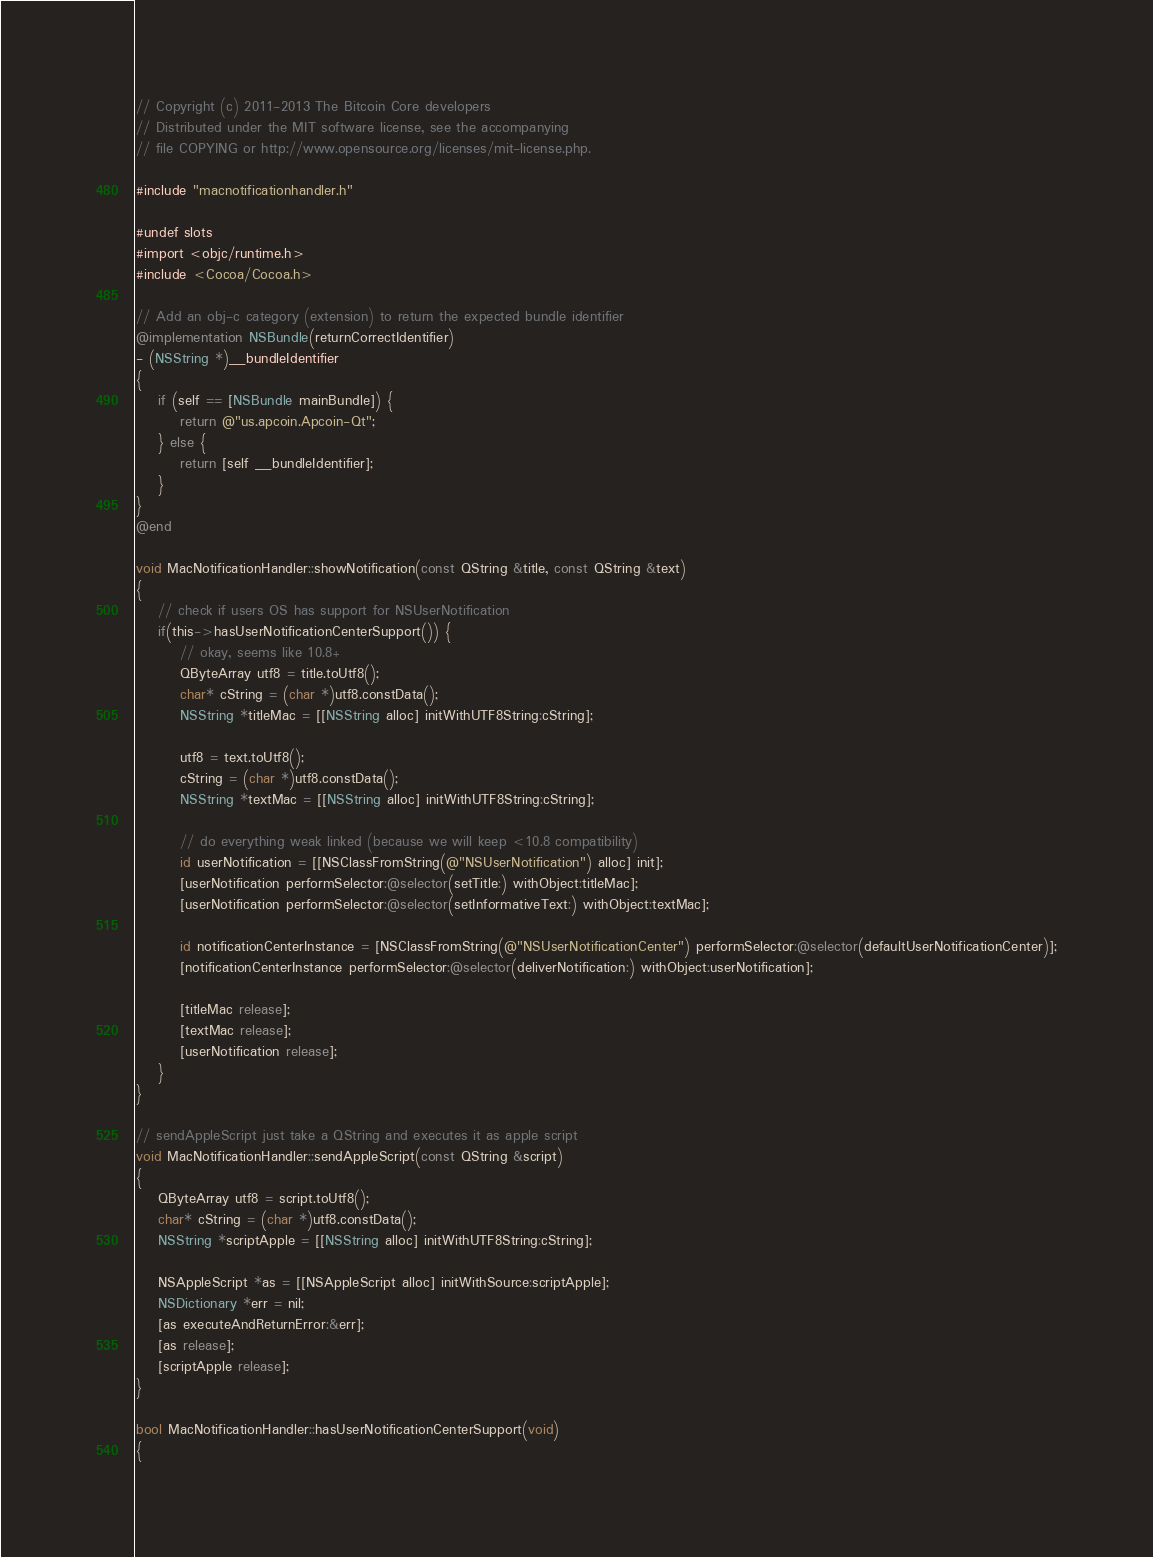Convert code to text. <code><loc_0><loc_0><loc_500><loc_500><_ObjectiveC_>// Copyright (c) 2011-2013 The Bitcoin Core developers
// Distributed under the MIT software license, see the accompanying
// file COPYING or http://www.opensource.org/licenses/mit-license.php.

#include "macnotificationhandler.h"

#undef slots
#import <objc/runtime.h>
#include <Cocoa/Cocoa.h>

// Add an obj-c category (extension) to return the expected bundle identifier
@implementation NSBundle(returnCorrectIdentifier)
- (NSString *)__bundleIdentifier
{
    if (self == [NSBundle mainBundle]) {
        return @"us.apcoin.Apcoin-Qt";
    } else {
        return [self __bundleIdentifier];
    }
}
@end

void MacNotificationHandler::showNotification(const QString &title, const QString &text)
{
    // check if users OS has support for NSUserNotification
    if(this->hasUserNotificationCenterSupport()) {
        // okay, seems like 10.8+
        QByteArray utf8 = title.toUtf8();
        char* cString = (char *)utf8.constData();
        NSString *titleMac = [[NSString alloc] initWithUTF8String:cString];

        utf8 = text.toUtf8();
        cString = (char *)utf8.constData();
        NSString *textMac = [[NSString alloc] initWithUTF8String:cString];

        // do everything weak linked (because we will keep <10.8 compatibility)
        id userNotification = [[NSClassFromString(@"NSUserNotification") alloc] init];
        [userNotification performSelector:@selector(setTitle:) withObject:titleMac];
        [userNotification performSelector:@selector(setInformativeText:) withObject:textMac];

        id notificationCenterInstance = [NSClassFromString(@"NSUserNotificationCenter") performSelector:@selector(defaultUserNotificationCenter)];
        [notificationCenterInstance performSelector:@selector(deliverNotification:) withObject:userNotification];

        [titleMac release];
        [textMac release];
        [userNotification release];
    }
}

// sendAppleScript just take a QString and executes it as apple script
void MacNotificationHandler::sendAppleScript(const QString &script)
{
    QByteArray utf8 = script.toUtf8();
    char* cString = (char *)utf8.constData();
    NSString *scriptApple = [[NSString alloc] initWithUTF8String:cString];

    NSAppleScript *as = [[NSAppleScript alloc] initWithSource:scriptApple];
    NSDictionary *err = nil;
    [as executeAndReturnError:&err];
    [as release];
    [scriptApple release];
}

bool MacNotificationHandler::hasUserNotificationCenterSupport(void)
{</code> 